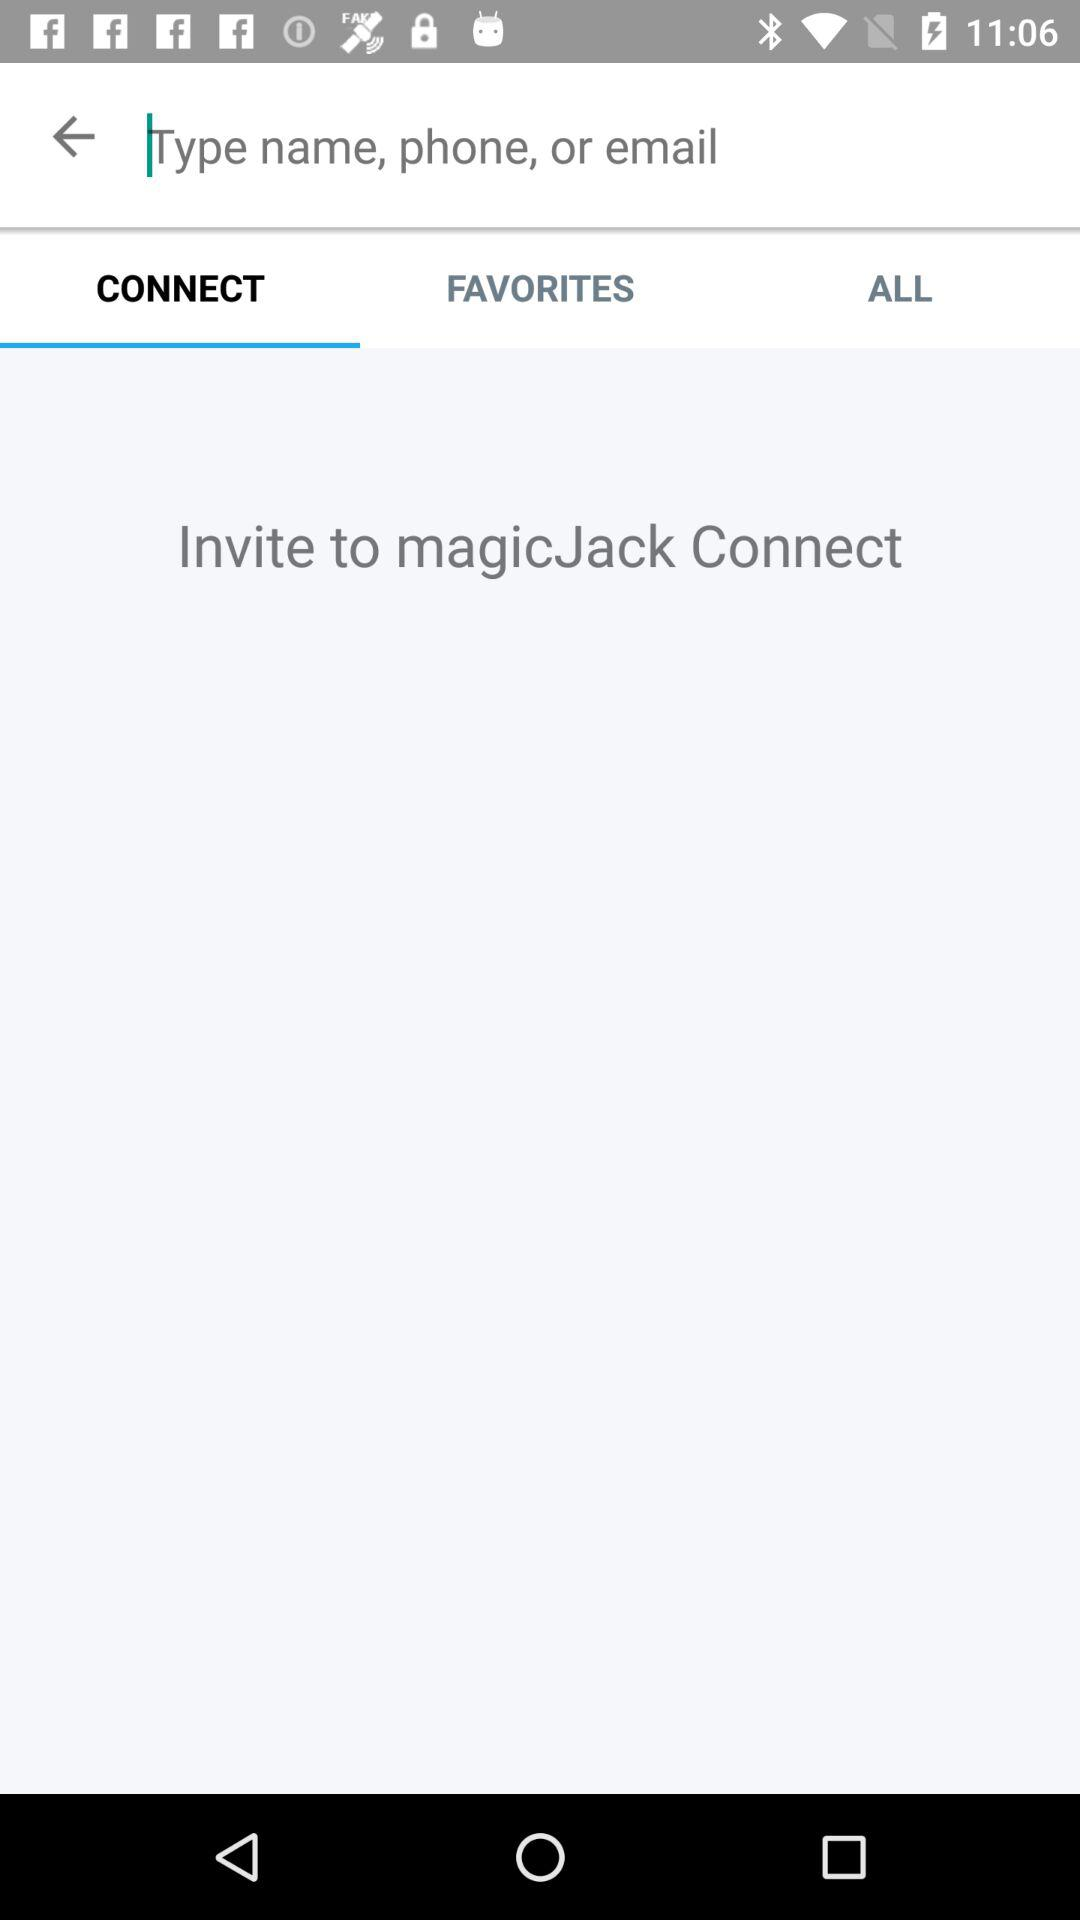Where should I invite people? You should invite people to "magicJack Connect". 